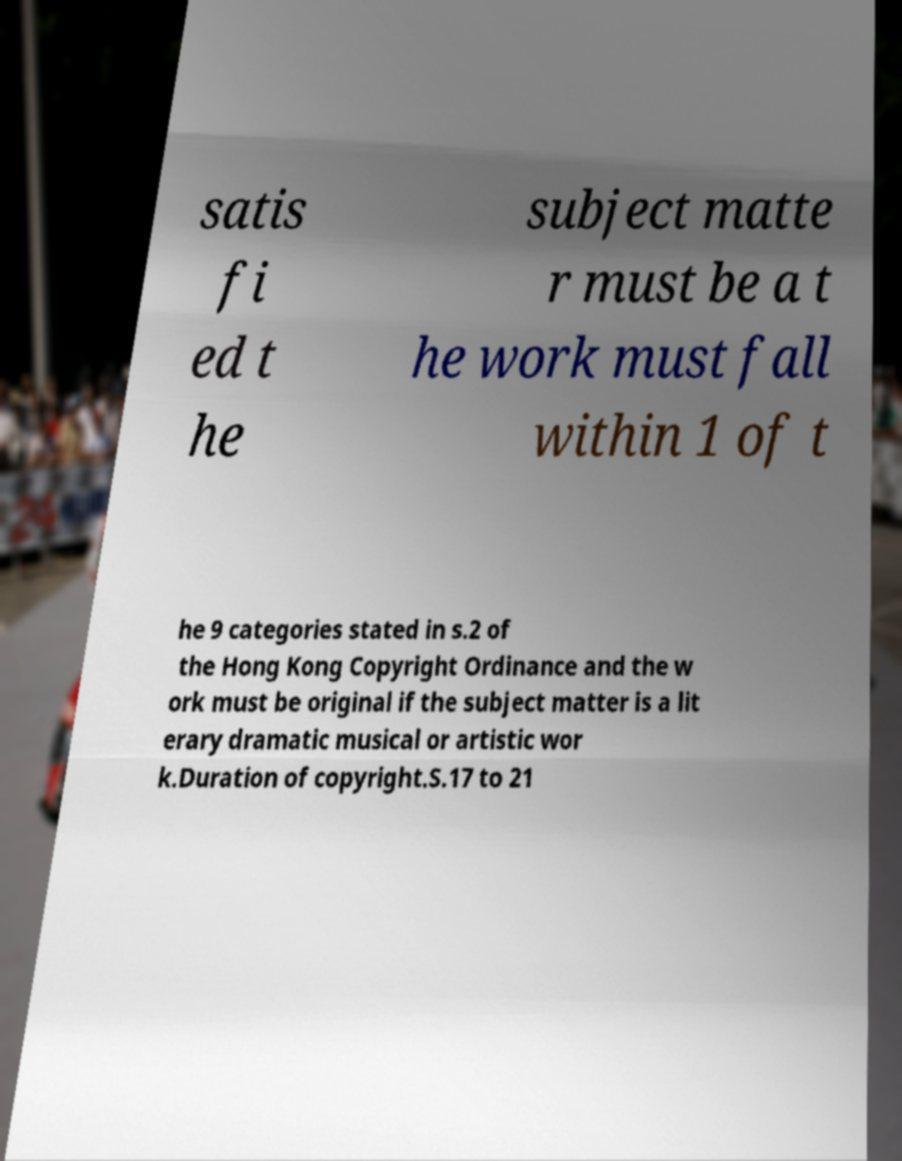Could you assist in decoding the text presented in this image and type it out clearly? satis fi ed t he subject matte r must be a t he work must fall within 1 of t he 9 categories stated in s.2 of the Hong Kong Copyright Ordinance and the w ork must be original if the subject matter is a lit erary dramatic musical or artistic wor k.Duration of copyright.S.17 to 21 